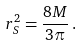Convert formula to latex. <formula><loc_0><loc_0><loc_500><loc_500>r _ { S } ^ { 2 } = \frac { 8 M } { 3 \pi } \, .</formula> 